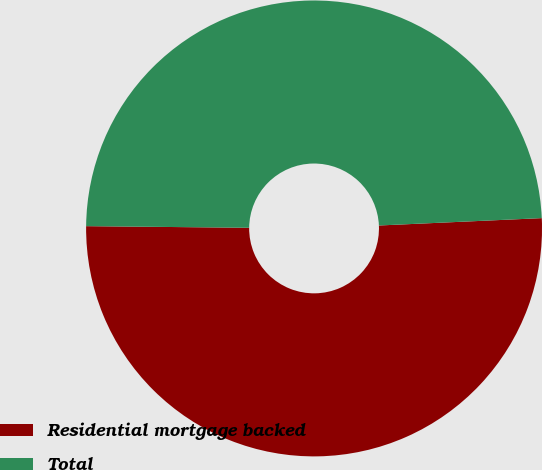Convert chart. <chart><loc_0><loc_0><loc_500><loc_500><pie_chart><fcel>Residential mortgage backed<fcel>Total<nl><fcel>50.88%<fcel>49.12%<nl></chart> 